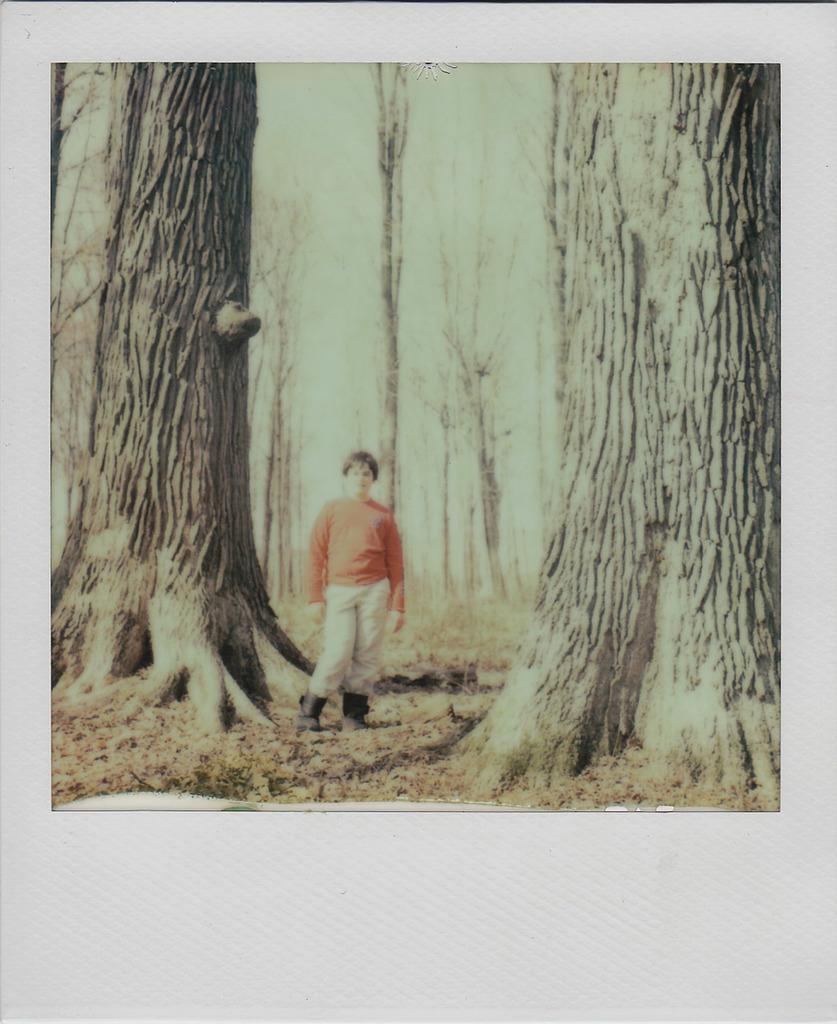What is the main subject of the picture? The main subject of the picture is a person. Where is the person located in relation to the trees? The person is standing between two tree trunks. What type of curtain can be seen hanging from the tree branches in the image? There is no curtain present in the image; it features a person standing between two tree trunks. What is the purpose of the person's presence in the image? The purpose of the person's presence in the image cannot be determined from the image alone, as it may vary depending on the context or intention of the photographer. 